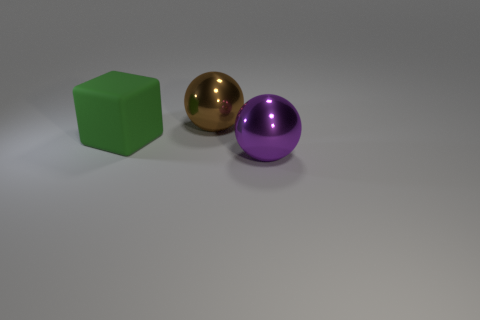Is there anything else that has the same color as the block?
Provide a short and direct response. No. The big sphere in front of the sphere that is behind the big green matte thing is what color?
Give a very brief answer. Purple. What is the big sphere on the left side of the shiny object in front of the large object behind the big green cube made of?
Provide a short and direct response. Metal. What number of other brown shiny spheres have the same size as the brown metal sphere?
Offer a very short reply. 0. What material is the object that is both in front of the brown object and on the left side of the purple ball?
Give a very brief answer. Rubber. What number of big brown objects are behind the brown shiny thing?
Ensure brevity in your answer.  0. Is the shape of the brown object the same as the large object in front of the matte cube?
Your answer should be very brief. Yes. Are there any brown things that have the same shape as the purple shiny thing?
Provide a short and direct response. Yes. The metallic thing left of the sphere that is in front of the large brown metal thing is what shape?
Your answer should be compact. Sphere. What shape is the metal object in front of the brown sphere?
Keep it short and to the point. Sphere. 